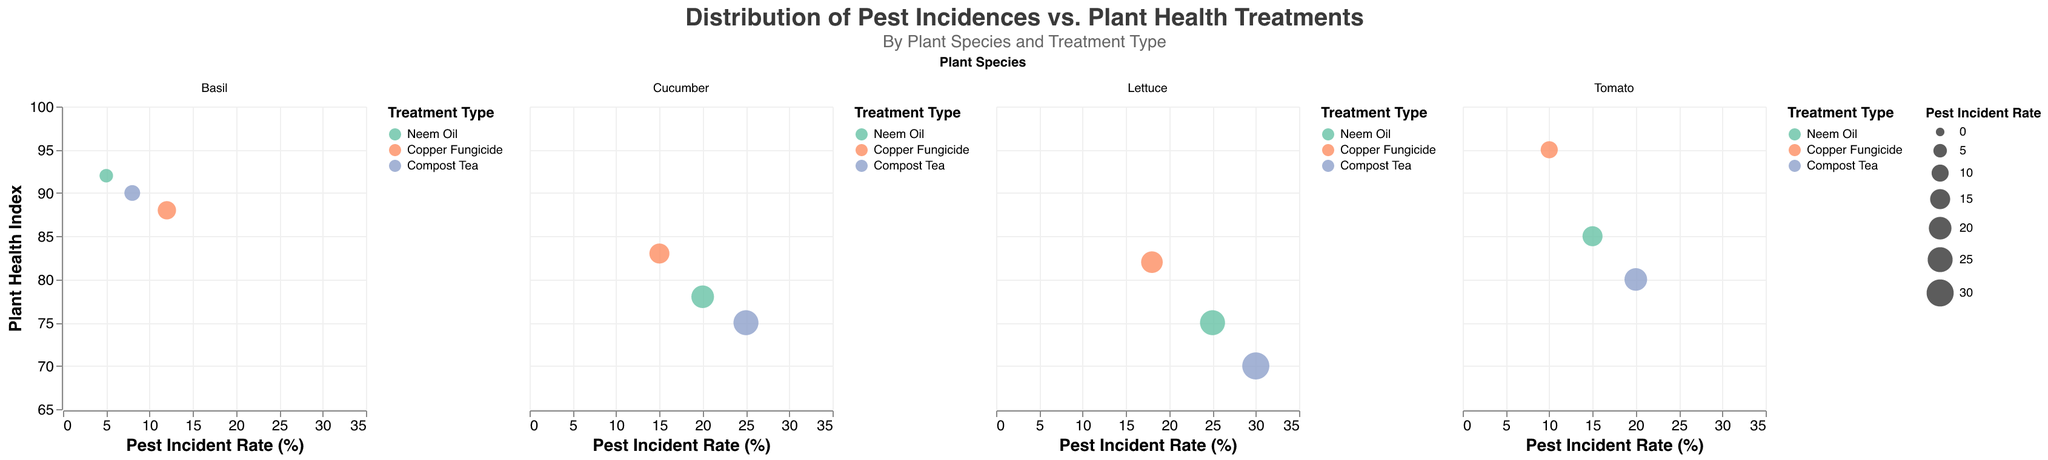What is the title of the figure? The title is usually at the top of the figure and specifies its main purpose or content. In this case, it reads "Distribution of Pest Incidences vs. Plant Health Treatments".
Answer: Distribution of Pest Incidences vs. Plant Health Treatments How many plant species are shown in the figure? By counting the facets, we see that the figure presents data for four different plant species: Tomato, Lettuce, Basil, and Cucumber.
Answer: Four Which plant species has the highest plant health index with Copper Fungicide treatment? Look for the plant species treated with Copper Fungicide (represented by a specific color). Then compare their Plant Health Indexes. Tomato with Copper Fungicide has a Plant Health Index of 95, which is the highest.
Answer: Tomato What is the average pest incident rate for plants treated with Neem Oil? Identify all Neem Oil treatment data points and sum their pest incident rates (15 + 25 + 5 + 20). Then, divide by the number of points (4). Calculation: (15 + 25 + 5 + 20) / 4 = 65 / 4 = 16.25.
Answer: 16.25 Which treatment type shows the broadest range of pest incident rates among all plant species? Examine the range of values for each treatment type. Compost Tea ranges from 8% to 30%, Neem Oil from 5% to 25%, and Copper Fungicide from 10% to 18%. The range for Compost Tea (22 units) is the broadest.
Answer: Compost Tea In which region does Basil experience the lowest pest incident rate, and what is the corresponding plant health index? For Basil, find the lowest pest incident rate and note its region. The lowest pest incident rate for Basil is 5% in the Central region with a Plant Health Index of 92.
Answer: Central, 92 Compare the pest incident rates of Lettuce treated with Copper Fungicide and Neem Oil. Which one is higher and by how much? Locate Lettuce treatments with Copper Fungicide and Neem Oil. Their pest incident rates are 18% and 25%, respectively. Neem Oil's treatment has a higher rate by 25 - 18 = 7%.
Answer: Neem Oil by 7% Which plant species has the smallest bubble for any treatment, and what is the pest incident rate for that treatment? The size of a bubble represents the pest incident rate. The smallest bubble appears for Basil treated with Neem Oil, which has a pest incident rate of 5%.
Answer: Basil with Neem Oil, 5% How does the plant health index of Cucumber treated with Neem Oil compare to its plant health index when treated with Compost Tea? Look at Cucumber and compare the Plant Health Index for Neem Oil (78) and Compost Tea (75). Neem Oil treatment has a higher health index by 78 - 75 = 3.
Answer: Neem Oil is 3 points higher 